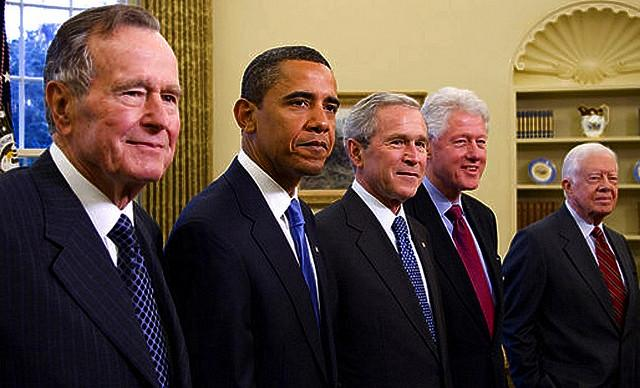Who is the second man from the left? obama 